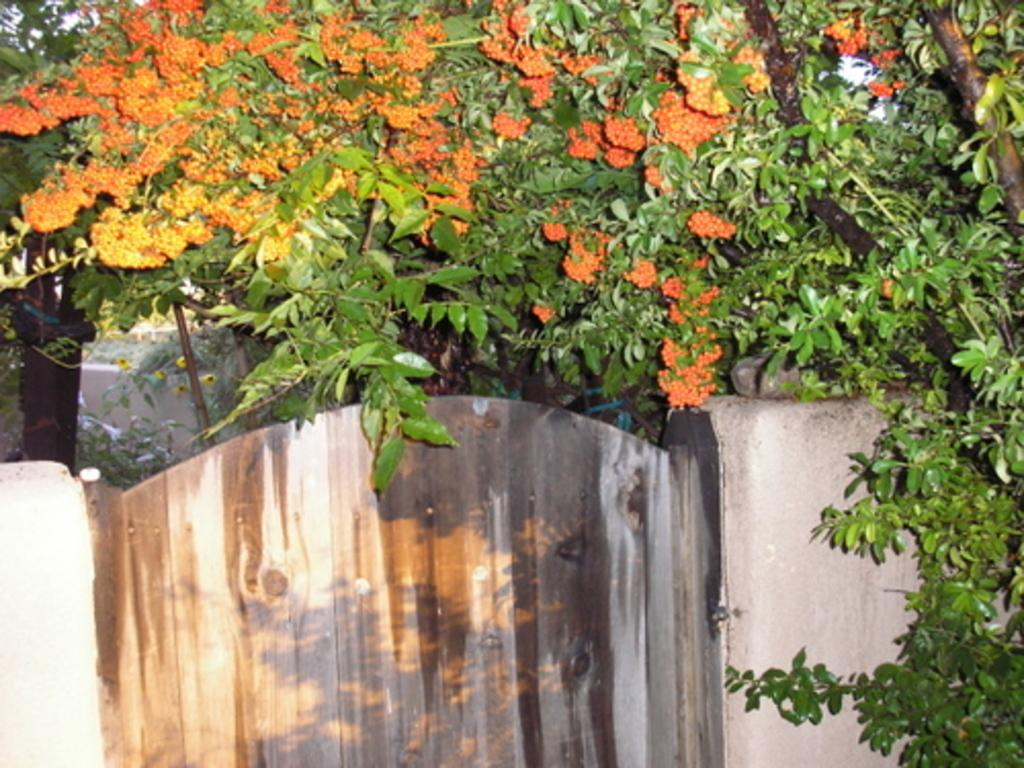What type of vegetation can be seen in the image? There are trees in the image. Are there any specific features on the trees? Yes, flowers are present on the trees. What structure is located at the bottom of the image? There is a gate at the bottom of the image. What is the gate attached to? The gate is attached to a wall. Can you describe the wall in the image? There is a wall visible in the image. What type of bean is growing on the wall in the image? There is no bean growing on the wall in the image; it features trees with flowers and a gate attached to a wall. Can you hear a whistle in the image? There is no whistle present in the image; it only contains visual elements. 